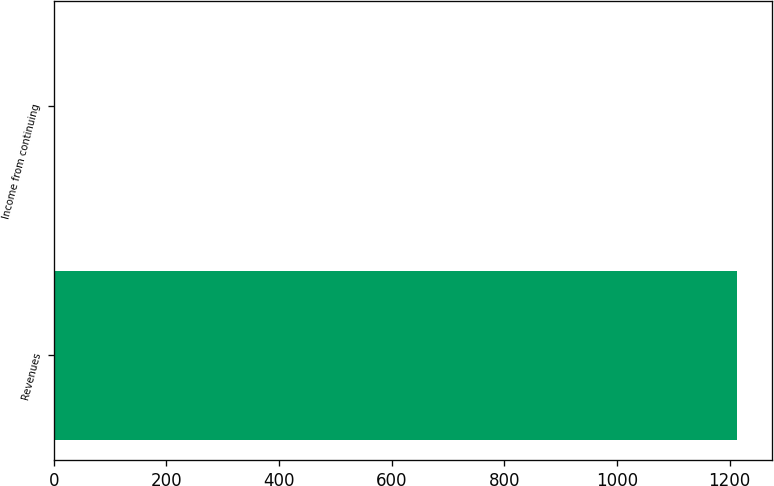<chart> <loc_0><loc_0><loc_500><loc_500><bar_chart><fcel>Revenues<fcel>Income from continuing<nl><fcel>1213.9<fcel>1.32<nl></chart> 